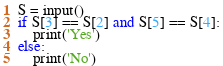<code> <loc_0><loc_0><loc_500><loc_500><_Python_>S = input()
if S[3] == S[2] and S[5] == S[4]:
    print('Yes')
else:
    print('No')</code> 